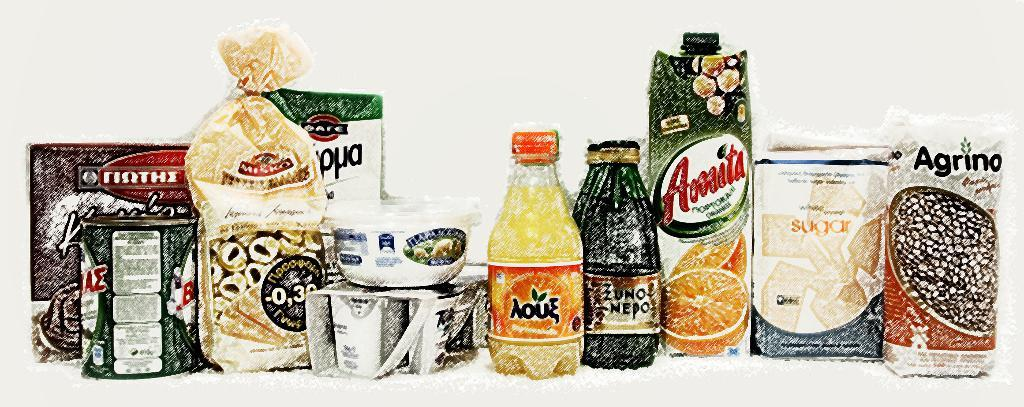Provide a one-sentence caption for the provided image. several food items are lined up, including a container of Amita. 